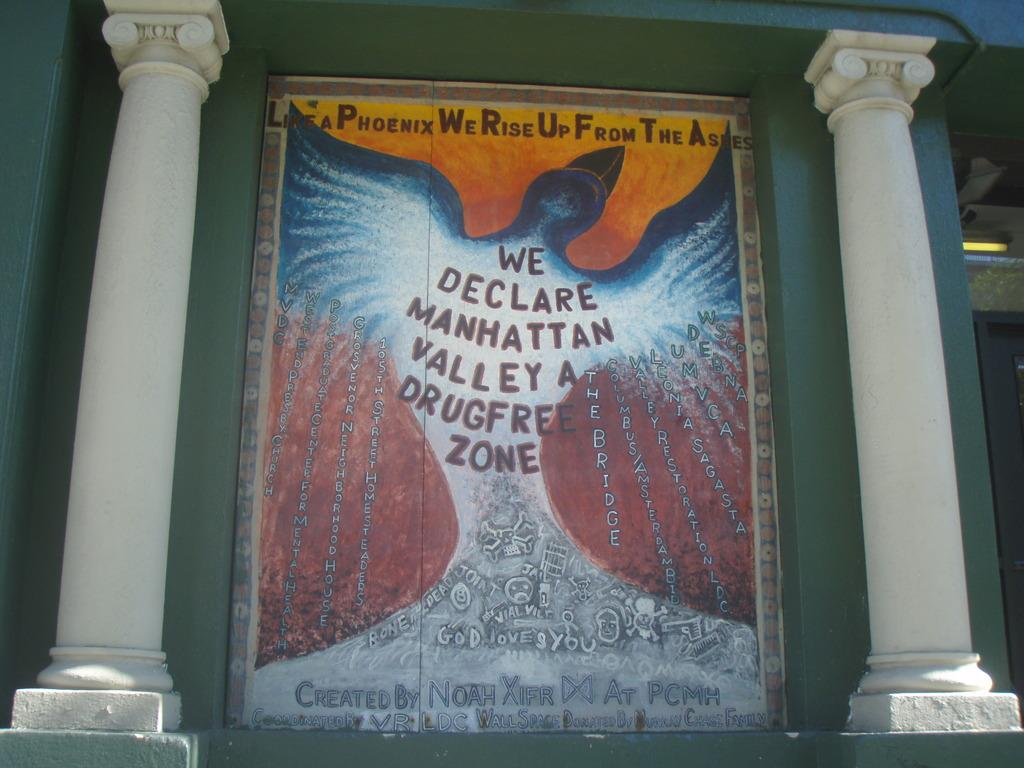<image>
Render a clear and concise summary of the photo. Poster that says "A Phoenix We Rise Up From The Ashes" showing a phoenix in the background. 